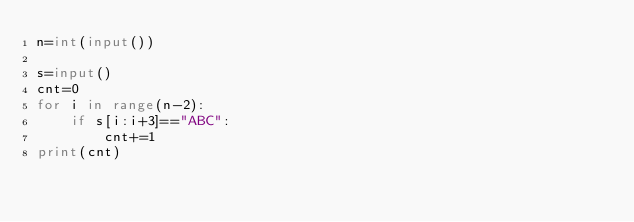Convert code to text. <code><loc_0><loc_0><loc_500><loc_500><_Python_>n=int(input())

s=input()
cnt=0
for i in range(n-2):
    if s[i:i+3]=="ABC":
        cnt+=1
print(cnt)
</code> 